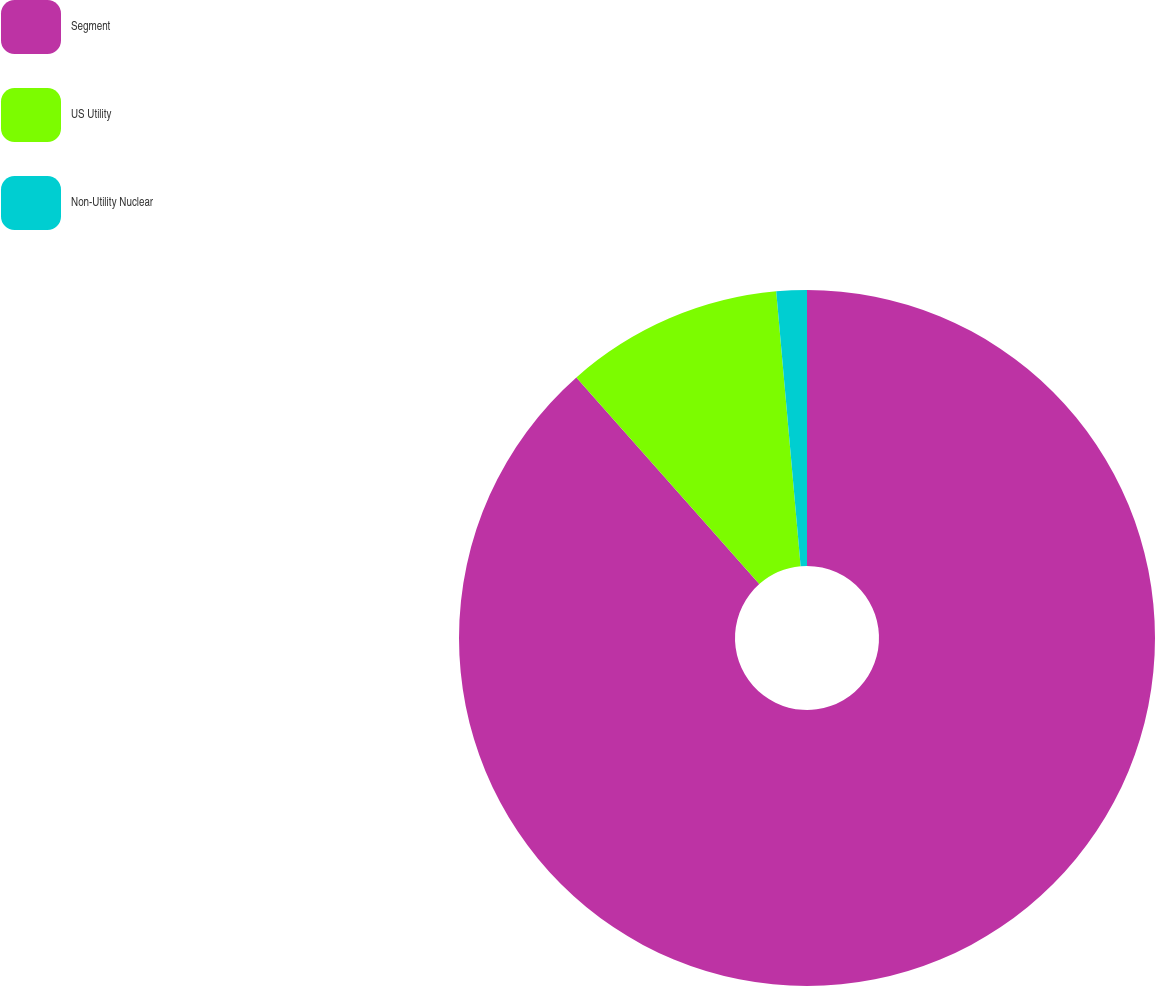Convert chart. <chart><loc_0><loc_0><loc_500><loc_500><pie_chart><fcel>Segment<fcel>US Utility<fcel>Non-Utility Nuclear<nl><fcel>88.47%<fcel>10.12%<fcel>1.41%<nl></chart> 